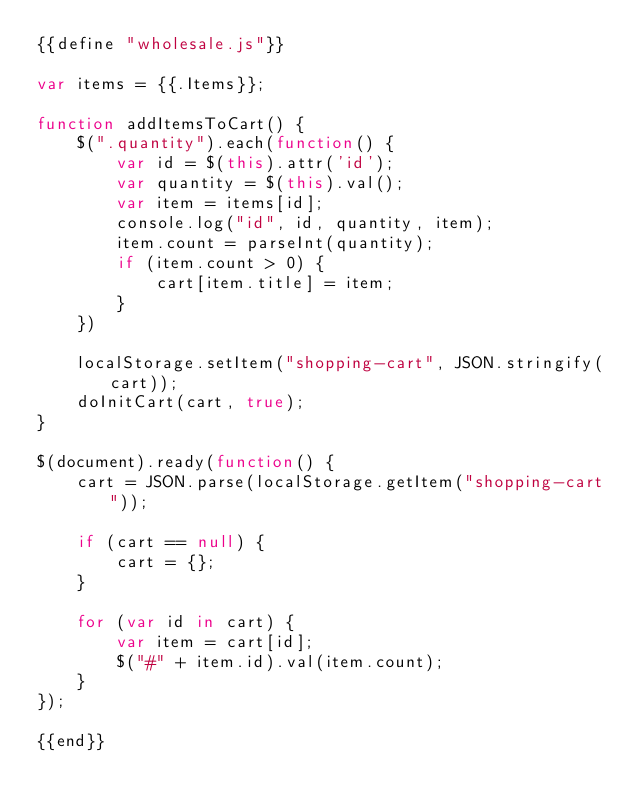Convert code to text. <code><loc_0><loc_0><loc_500><loc_500><_JavaScript_>{{define "wholesale.js"}}

var items = {{.Items}};

function addItemsToCart() {
    $(".quantity").each(function() {
        var id = $(this).attr('id');
        var quantity = $(this).val();
        var item = items[id];
        console.log("id", id, quantity, item);
        item.count = parseInt(quantity);
        if (item.count > 0) {
            cart[item.title] = item;
        }
    })
    
    localStorage.setItem("shopping-cart", JSON.stringify(cart));
    doInitCart(cart, true);
}

$(document).ready(function() {
    cart = JSON.parse(localStorage.getItem("shopping-cart"));
    
    if (cart == null) {
        cart = {};
    }

    for (var id in cart) {
        var item = cart[id];
        $("#" + item.id).val(item.count);
    }
});

{{end}}
</code> 